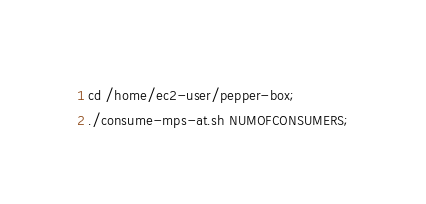Convert code to text. <code><loc_0><loc_0><loc_500><loc_500><_Bash_>cd /home/ec2-user/pepper-box;
./consume-mps-at.sh NUMOFCONSUMERS;
</code> 